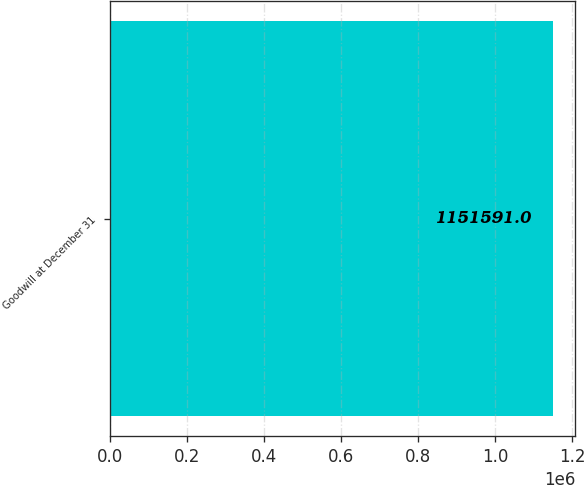Convert chart to OTSL. <chart><loc_0><loc_0><loc_500><loc_500><bar_chart><fcel>Goodwill at December 31<nl><fcel>1.15159e+06<nl></chart> 